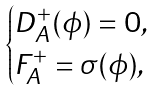Convert formula to latex. <formula><loc_0><loc_0><loc_500><loc_500>\begin{cases} D ^ { + } _ { A } ( \phi ) = 0 , \\ F ^ { + } _ { A } = \sigma ( \phi ) , \end{cases}</formula> 